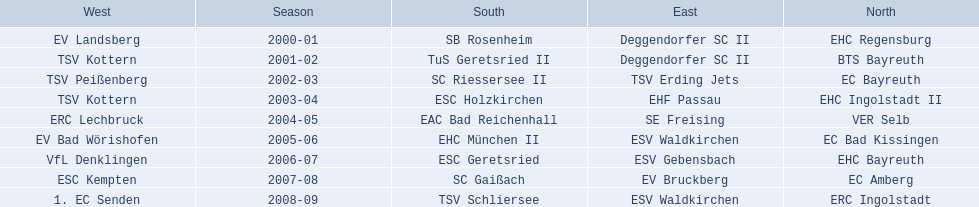Which teams won the north in their respective years? 2000-01, EHC Regensburg, BTS Bayreuth, EC Bayreuth, EHC Ingolstadt II, VER Selb, EC Bad Kissingen, EHC Bayreuth, EC Amberg, ERC Ingolstadt. Which one only won in 2000-01? EHC Regensburg. 